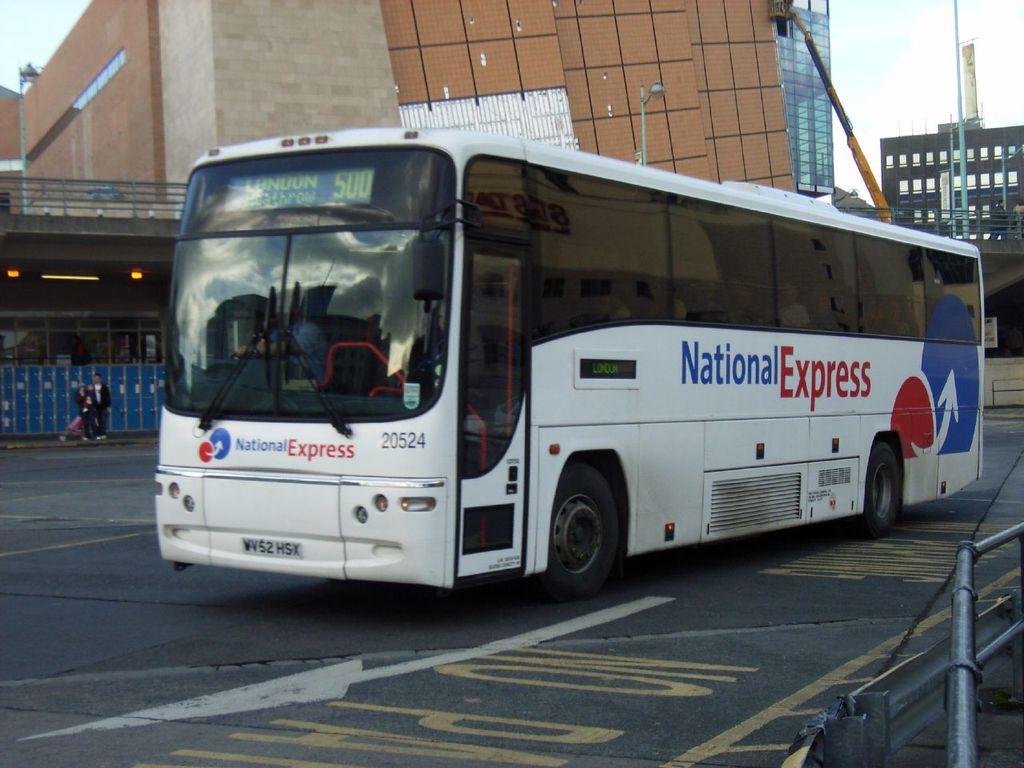What is the name of the bus company?
Your answer should be very brief. National express. What is the bus number?
Offer a terse response. 20524. 